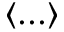Convert formula to latex. <formula><loc_0><loc_0><loc_500><loc_500>\langle \dots \rangle</formula> 